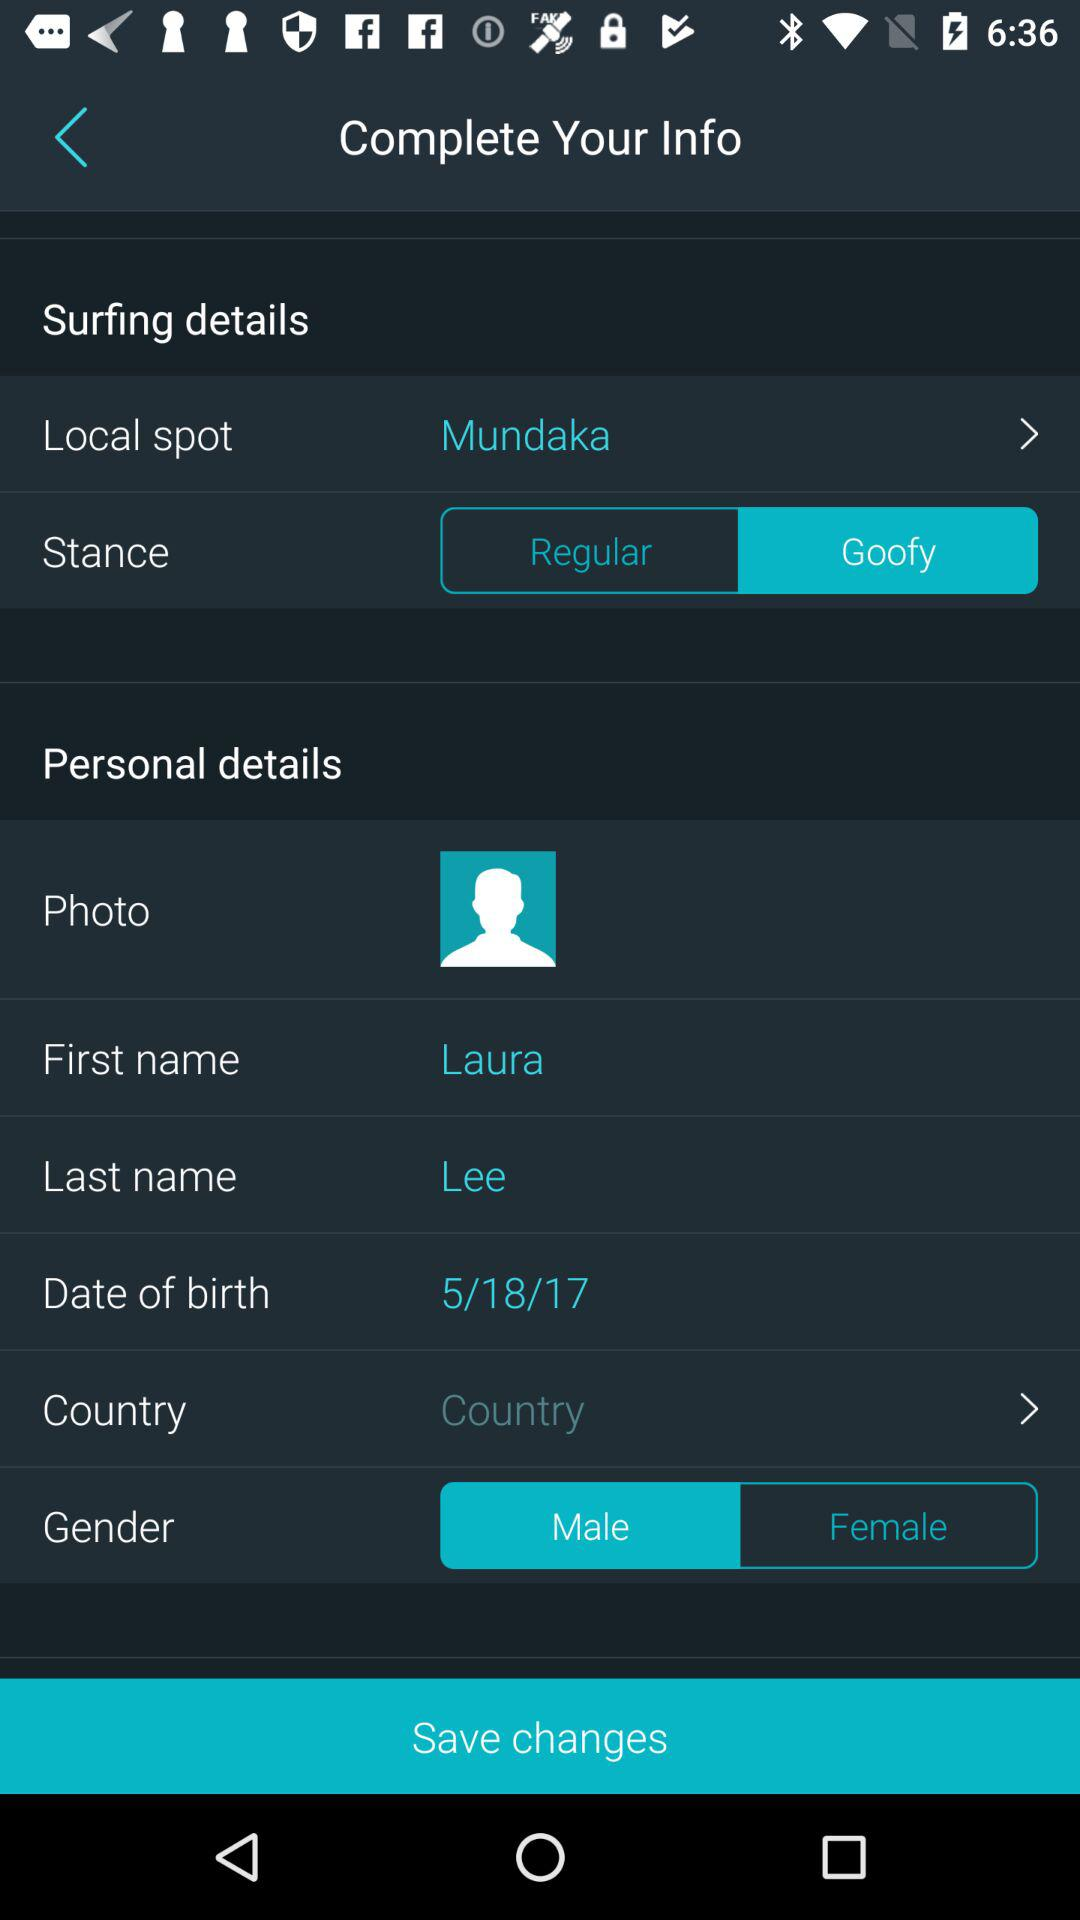What is the gender? The gender is male. 